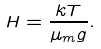Convert formula to latex. <formula><loc_0><loc_0><loc_500><loc_500>H = \frac { k T } { \mu _ { m } g } .</formula> 